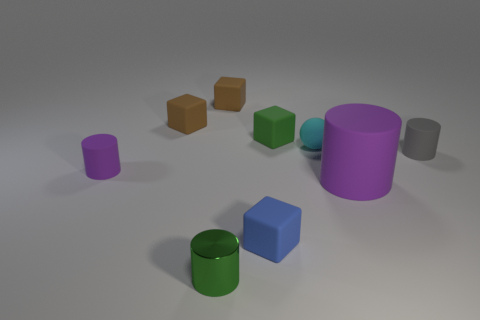Subtract 1 cylinders. How many cylinders are left? 3 Subtract all cyan blocks. Subtract all gray cylinders. How many blocks are left? 4 Subtract all balls. How many objects are left? 8 Subtract 0 cyan cylinders. How many objects are left? 9 Subtract all small green matte objects. Subtract all small green metallic cylinders. How many objects are left? 7 Add 5 spheres. How many spheres are left? 6 Add 7 gray metallic things. How many gray metallic things exist? 7 